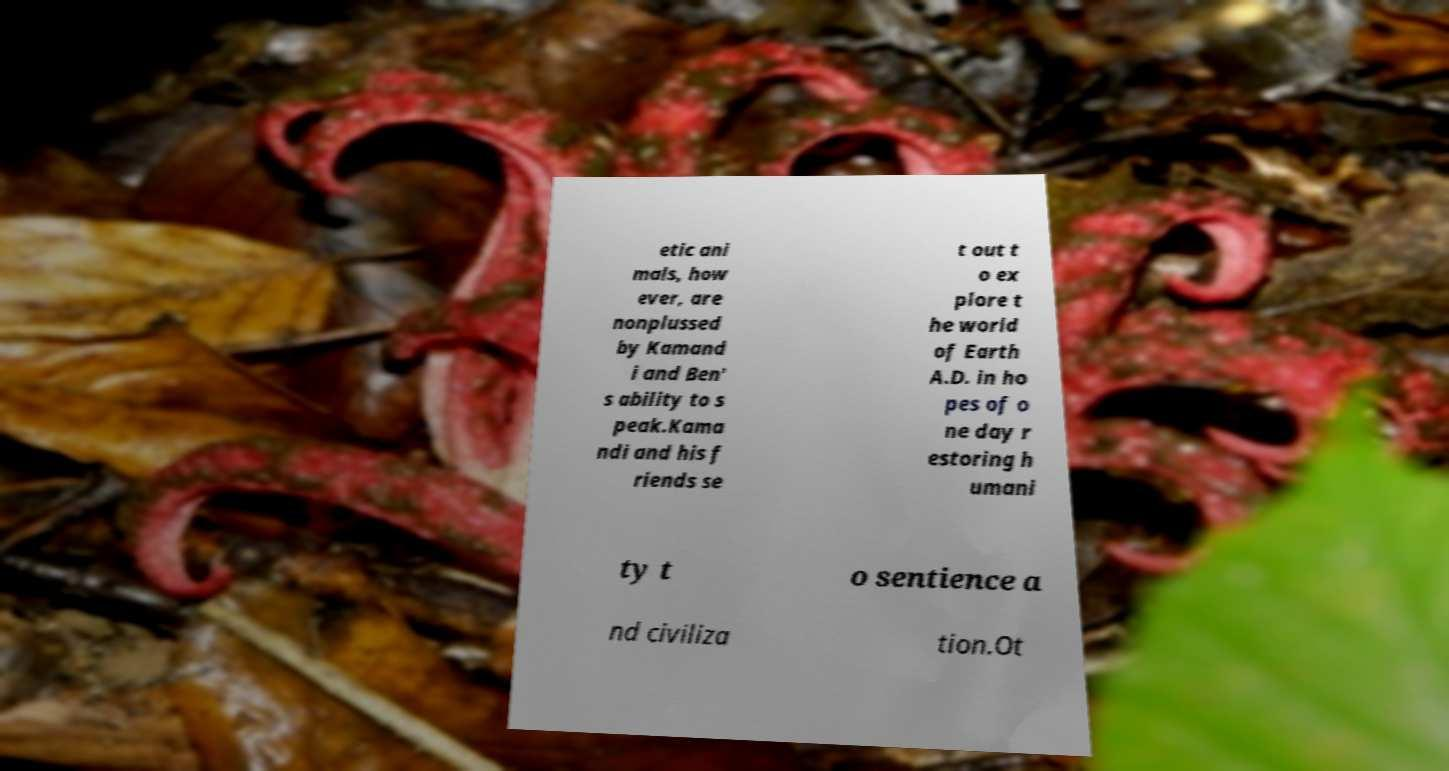What messages or text are displayed in this image? I need them in a readable, typed format. etic ani mals, how ever, are nonplussed by Kamand i and Ben' s ability to s peak.Kama ndi and his f riends se t out t o ex plore t he world of Earth A.D. in ho pes of o ne day r estoring h umani ty t o sentience a nd civiliza tion.Ot 